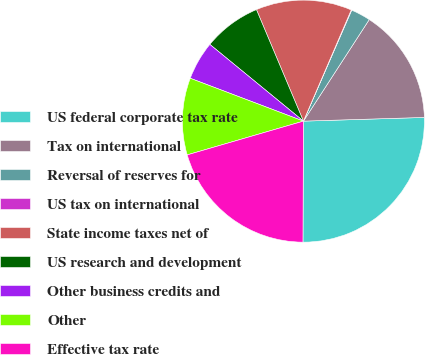Convert chart to OTSL. <chart><loc_0><loc_0><loc_500><loc_500><pie_chart><fcel>US federal corporate tax rate<fcel>Tax on international<fcel>Reversal of reserves for<fcel>US tax on international<fcel>State income taxes net of<fcel>US research and development<fcel>Other business credits and<fcel>Other<fcel>Effective tax rate<nl><fcel>25.55%<fcel>15.36%<fcel>2.62%<fcel>0.07%<fcel>12.81%<fcel>7.72%<fcel>5.17%<fcel>10.26%<fcel>20.44%<nl></chart> 